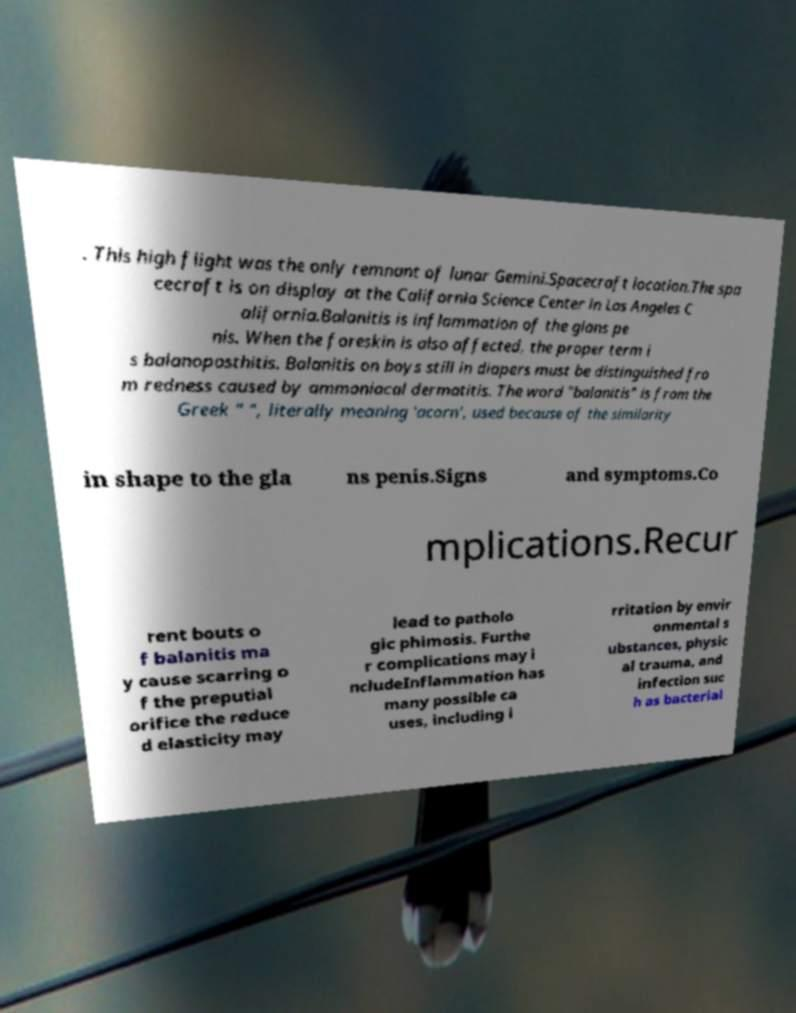Please identify and transcribe the text found in this image. . This high flight was the only remnant of lunar Gemini.Spacecraft location.The spa cecraft is on display at the California Science Center in Los Angeles C alifornia.Balanitis is inflammation of the glans pe nis. When the foreskin is also affected, the proper term i s balanoposthitis. Balanitis on boys still in diapers must be distinguished fro m redness caused by ammoniacal dermatitis. The word "balanitis" is from the Greek " ", literally meaning 'acorn', used because of the similarity in shape to the gla ns penis.Signs and symptoms.Co mplications.Recur rent bouts o f balanitis ma y cause scarring o f the preputial orifice the reduce d elasticity may lead to patholo gic phimosis. Furthe r complications may i ncludeInflammation has many possible ca uses, including i rritation by envir onmental s ubstances, physic al trauma, and infection suc h as bacterial 